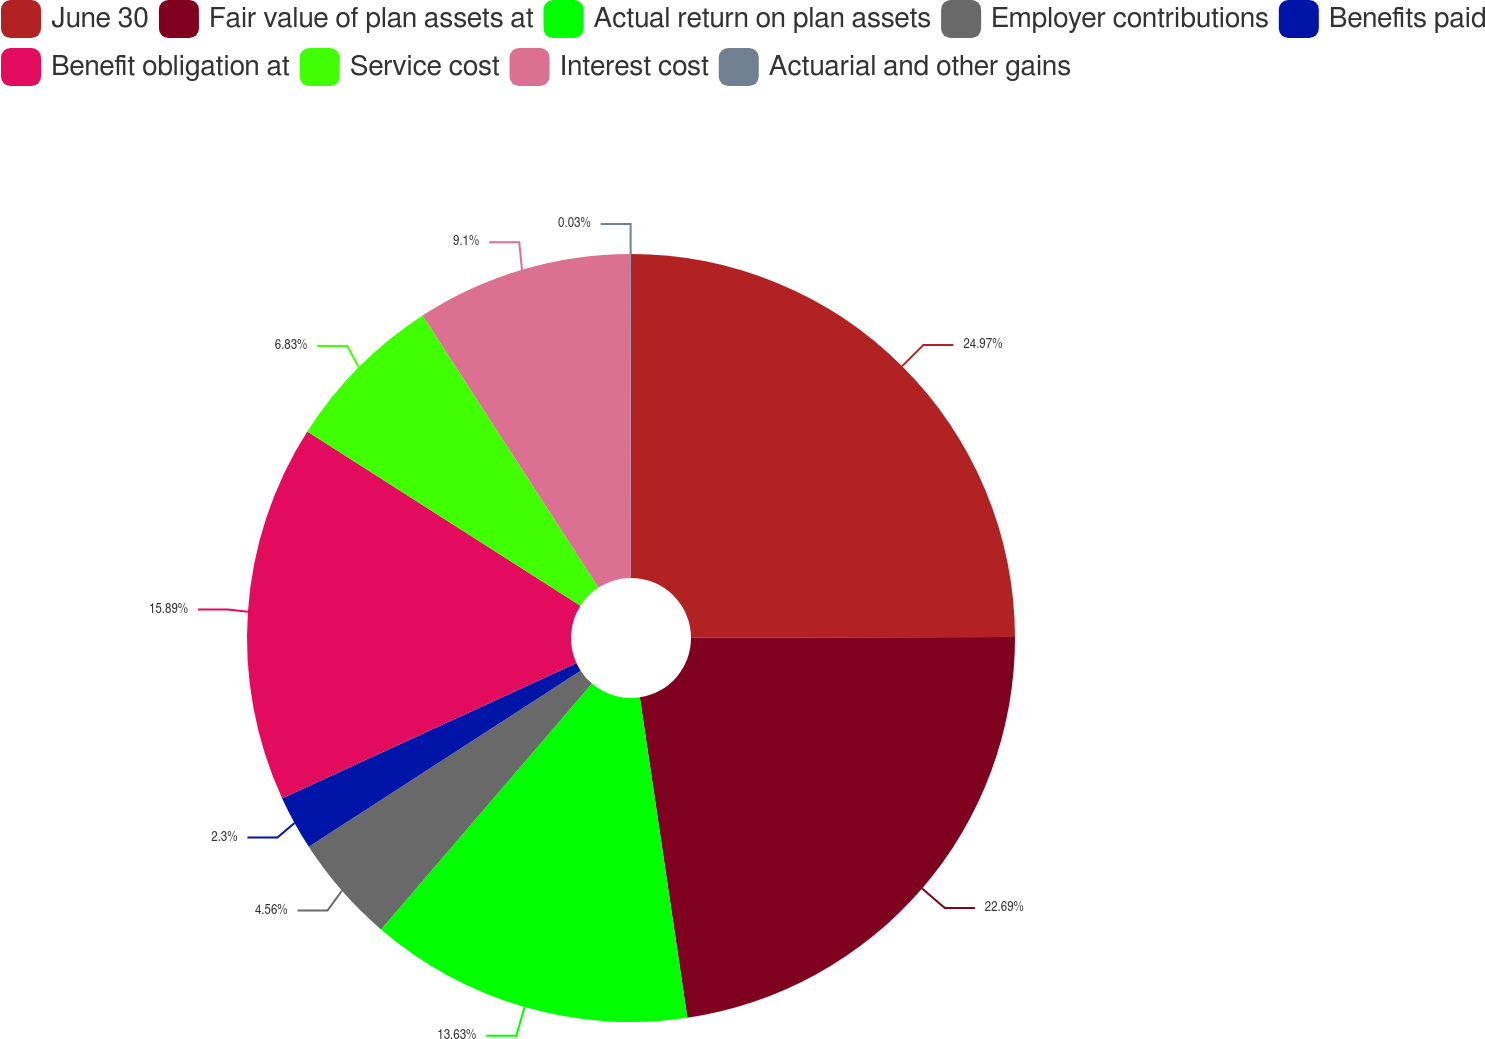Convert chart. <chart><loc_0><loc_0><loc_500><loc_500><pie_chart><fcel>June 30<fcel>Fair value of plan assets at<fcel>Actual return on plan assets<fcel>Employer contributions<fcel>Benefits paid<fcel>Benefit obligation at<fcel>Service cost<fcel>Interest cost<fcel>Actuarial and other gains<nl><fcel>24.96%<fcel>22.69%<fcel>13.63%<fcel>4.56%<fcel>2.3%<fcel>15.89%<fcel>6.83%<fcel>9.1%<fcel>0.03%<nl></chart> 